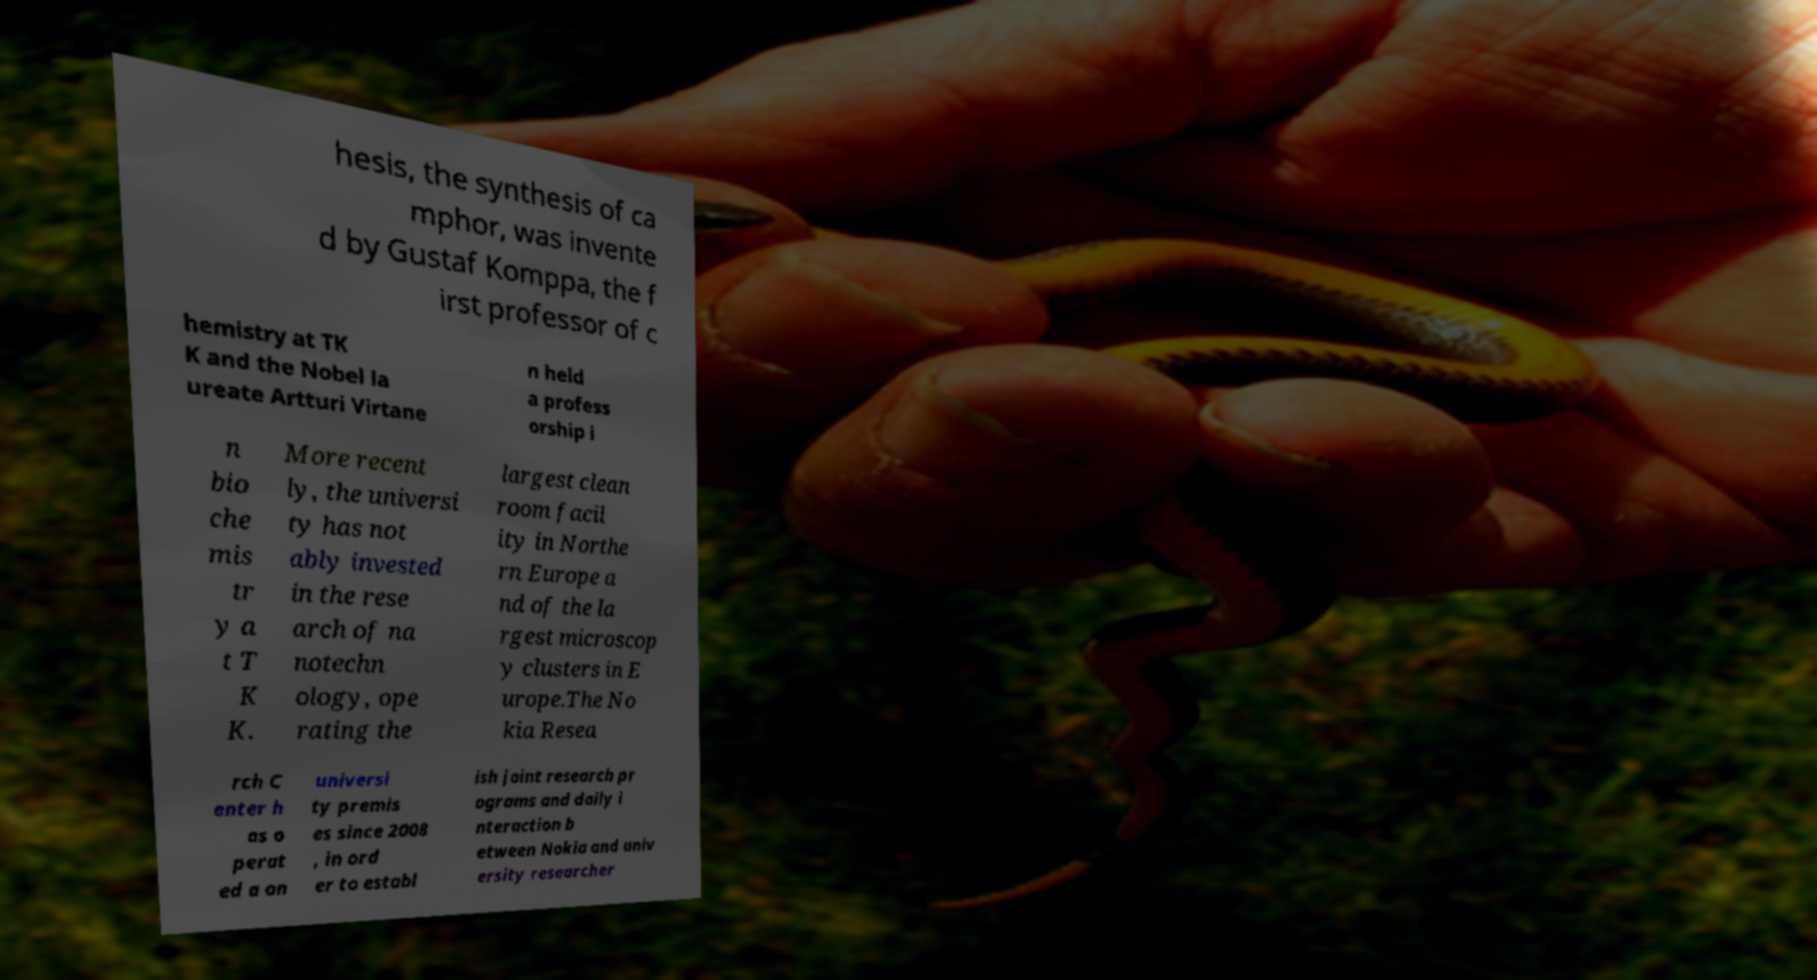There's text embedded in this image that I need extracted. Can you transcribe it verbatim? hesis, the synthesis of ca mphor, was invente d by Gustaf Komppa, the f irst professor of c hemistry at TK K and the Nobel la ureate Artturi Virtane n held a profess orship i n bio che mis tr y a t T K K. More recent ly, the universi ty has not ably invested in the rese arch of na notechn ology, ope rating the largest clean room facil ity in Northe rn Europe a nd of the la rgest microscop y clusters in E urope.The No kia Resea rch C enter h as o perat ed a on universi ty premis es since 2008 , in ord er to establ ish joint research pr ograms and daily i nteraction b etween Nokia and univ ersity researcher 